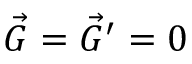Convert formula to latex. <formula><loc_0><loc_0><loc_500><loc_500>\vec { G } = \vec { G } ^ { \prime } = 0</formula> 